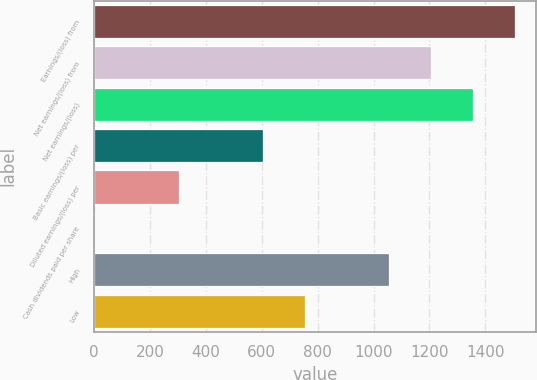<chart> <loc_0><loc_0><loc_500><loc_500><bar_chart><fcel>Earnings/(loss) from<fcel>Net earnings/(loss) from<fcel>Net earnings/(loss)<fcel>Basic earnings/(loss) per<fcel>Diluted earnings/(loss) per<fcel>Cash dividends paid per share<fcel>High<fcel>Low<nl><fcel>1506.03<fcel>1204.89<fcel>1355.46<fcel>602.62<fcel>301.49<fcel>0.35<fcel>1054.33<fcel>753.19<nl></chart> 